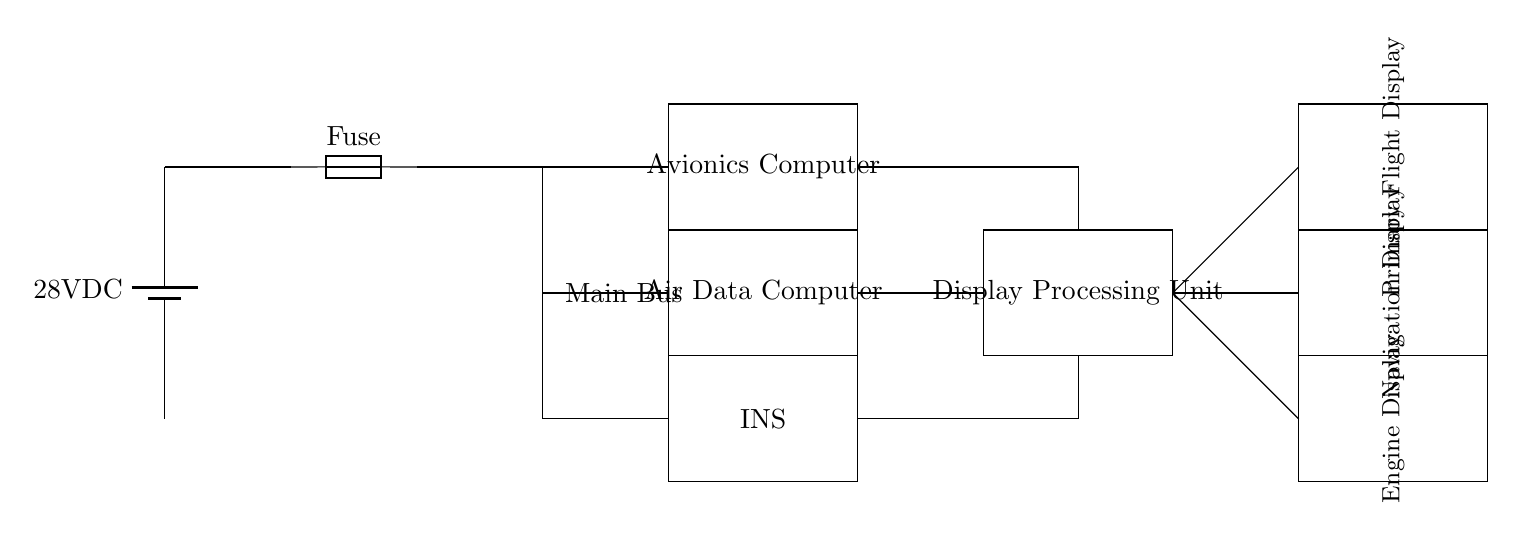What is the main voltage supplied to the circuit? The circuit is powered by a 28V DC battery, which can be seen marked at the top left of the diagram.
Answer: 28V DC What component connects the main power supply to the avionics computer? The circuit shows that a wire directly connects the battery to the fuse and subsequently to the avionics computer, indicating the flow of power.
Answer: Fuse How many avionics devices are integrated into the circuit? The diagram shows a total of three avionics devices: the Avionics Computer, Air Data Computer, and Inertial Navigation System.
Answer: Three What type of display is shown in the circuit diagram? The circuit includes three types of displays: Primary Flight Display, Navigation Display, and Engine Display, which are specified in the respective rectangles to the right.
Answer: Three displays Which component is responsible for processing the display data? The Display Processing Unit is shown to be connected to the avionics devices and displays, indicating its role in data processing before presentation.
Answer: Display Processing Unit From which component does the display receive data inputs? The display processing unit directly receives inputs from the avionics computer, air data computer, and inertial navigation system, all of which provide necessary data.
Answer: Avionics computer What does the fuse protect in this circuit? The fuse is used to protect the circuit from overcurrent, ensuring safe operation by interrupting the flow if current exceeds a certain limit.
Answer: Overcurrent protection 